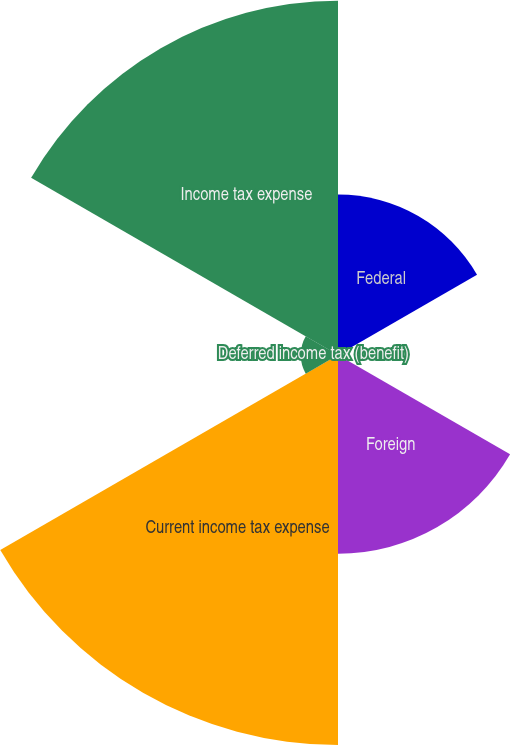<chart> <loc_0><loc_0><loc_500><loc_500><pie_chart><fcel>Federal<fcel>State<fcel>Foreign<fcel>Current income tax expense<fcel>Deferred income tax (benefit)<fcel>Income tax expense<nl><fcel>14.05%<fcel>0.15%<fcel>17.39%<fcel>34.13%<fcel>3.26%<fcel>31.01%<nl></chart> 